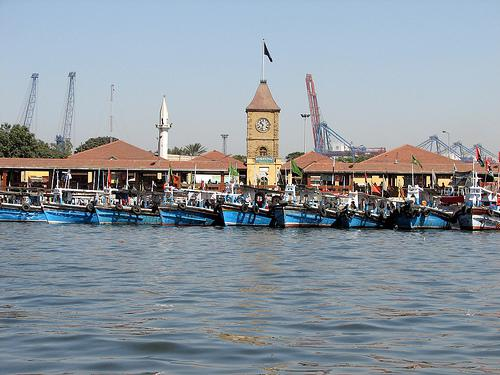Question: what color are the boats?
Choices:
A. Grey.
B. White.
C. Red.
D. Blue.
Answer with the letter. Answer: D Question: what is in the middle of the tower?
Choices:
A. Bell.
B. Bricks.
C. Wooden shutters.
D. A clock.
Answer with the letter. Answer: D Question: how is the water?
Choices:
A. Wavy.
B. Rough.
C. Dirty.
D. Calm.
Answer with the letter. Answer: D Question: how is the weather?
Choices:
A. Clear and cold.
B. Snowy.
C. Rainy.
D. Clear and sunny.
Answer with the letter. Answer: D Question: what is on top of the clock tower?
Choices:
A. A cross.
B. A statue.
C. A birt.
D. A flag.
Answer with the letter. Answer: D Question: what color are the roof?
Choices:
A. Red.
B. Tan.
C. Black.
D. White.
Answer with the letter. Answer: B Question: what is in the background?
Choices:
A. Several Cranes.
B. Flamingo.
C. Owl.
D. Hawk.
Answer with the letter. Answer: A 